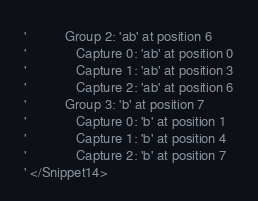Convert code to text. <code><loc_0><loc_0><loc_500><loc_500><_VisualBasic_>'          Group 2: 'ab' at position 6
'             Capture 0: 'ab' at position 0
'             Capture 1: 'ab' at position 3
'             Capture 2: 'ab' at position 6
'          Group 3: 'b' at position 7
'             Capture 0: 'b' at position 1
'             Capture 1: 'b' at position 4
'             Capture 2: 'b' at position 7
' </Snippet14>
</code> 